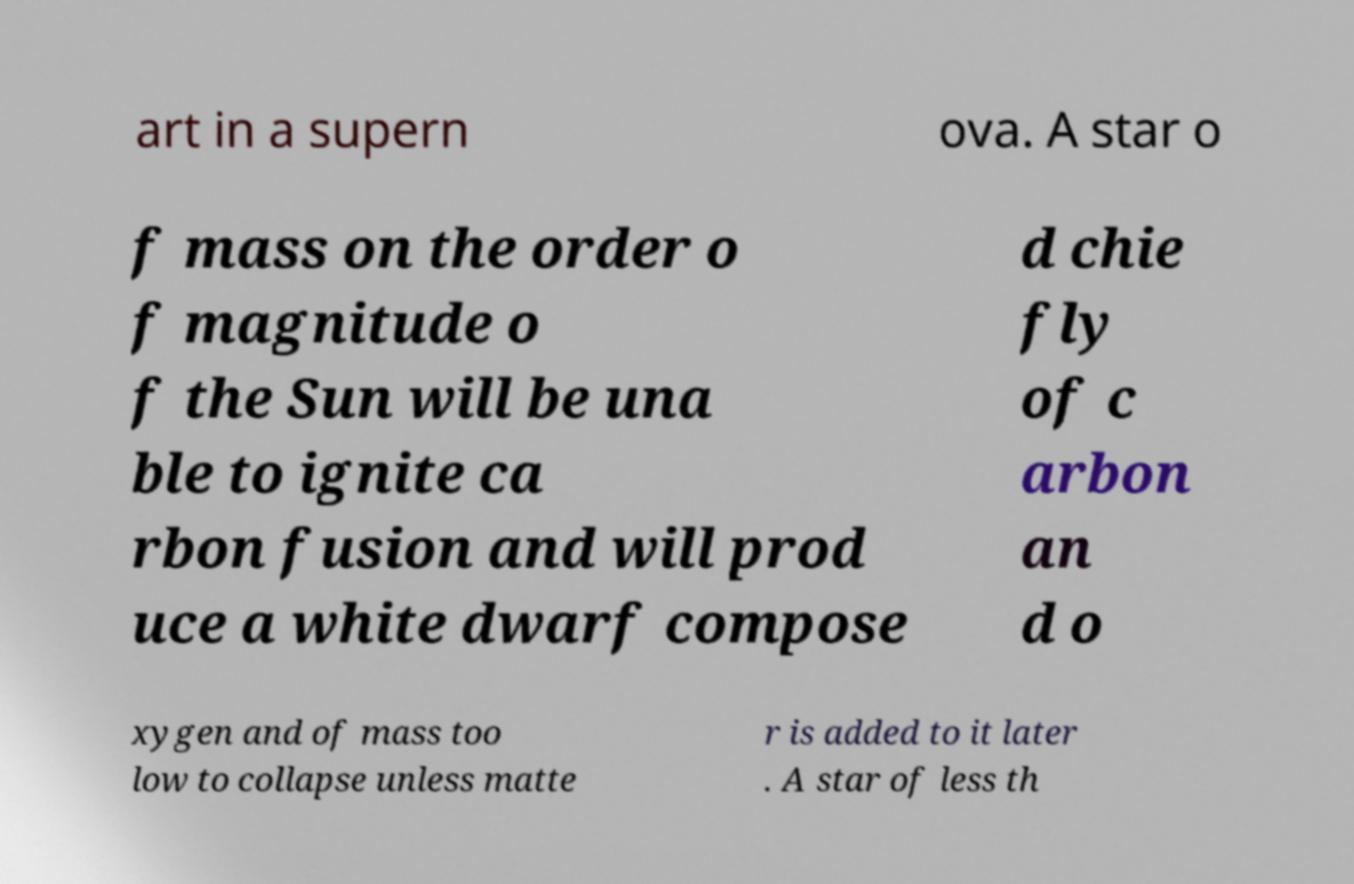Can you accurately transcribe the text from the provided image for me? art in a supern ova. A star o f mass on the order o f magnitude o f the Sun will be una ble to ignite ca rbon fusion and will prod uce a white dwarf compose d chie fly of c arbon an d o xygen and of mass too low to collapse unless matte r is added to it later . A star of less th 